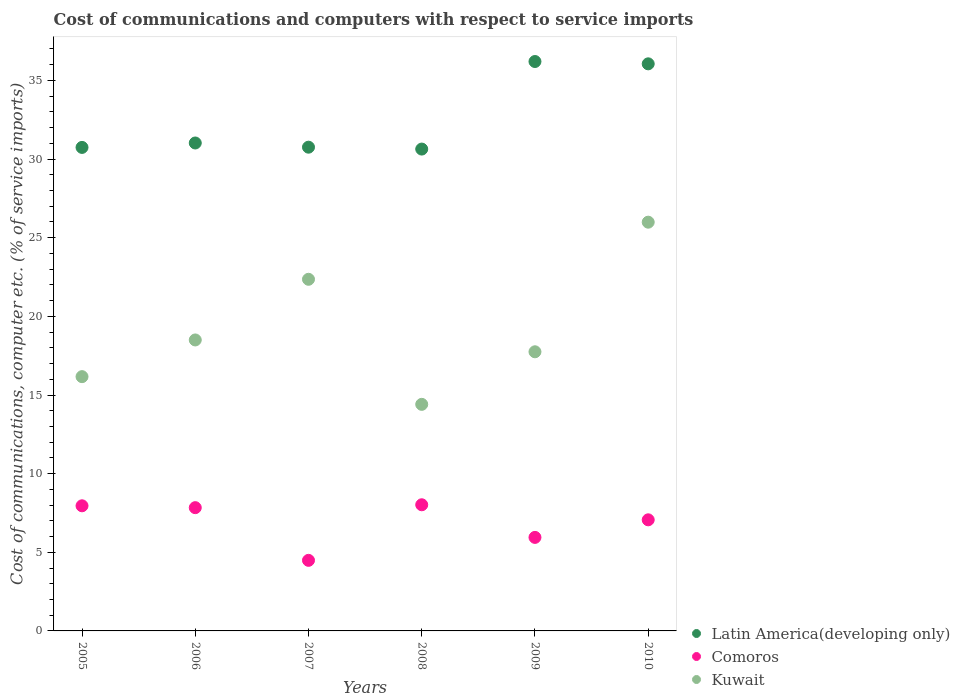Is the number of dotlines equal to the number of legend labels?
Provide a succinct answer. Yes. What is the cost of communications and computers in Kuwait in 2006?
Your response must be concise. 18.5. Across all years, what is the maximum cost of communications and computers in Latin America(developing only)?
Offer a terse response. 36.2. Across all years, what is the minimum cost of communications and computers in Kuwait?
Make the answer very short. 14.41. In which year was the cost of communications and computers in Comoros minimum?
Ensure brevity in your answer.  2007. What is the total cost of communications and computers in Latin America(developing only) in the graph?
Provide a succinct answer. 195.42. What is the difference between the cost of communications and computers in Comoros in 2006 and that in 2008?
Offer a very short reply. -0.18. What is the difference between the cost of communications and computers in Kuwait in 2008 and the cost of communications and computers in Comoros in 2009?
Your response must be concise. 8.46. What is the average cost of communications and computers in Latin America(developing only) per year?
Provide a short and direct response. 32.57. In the year 2010, what is the difference between the cost of communications and computers in Comoros and cost of communications and computers in Latin America(developing only)?
Provide a succinct answer. -28.99. What is the ratio of the cost of communications and computers in Kuwait in 2009 to that in 2010?
Provide a short and direct response. 0.68. Is the cost of communications and computers in Kuwait in 2008 less than that in 2009?
Make the answer very short. Yes. Is the difference between the cost of communications and computers in Comoros in 2005 and 2007 greater than the difference between the cost of communications and computers in Latin America(developing only) in 2005 and 2007?
Keep it short and to the point. Yes. What is the difference between the highest and the second highest cost of communications and computers in Comoros?
Give a very brief answer. 0.07. What is the difference between the highest and the lowest cost of communications and computers in Latin America(developing only)?
Give a very brief answer. 5.57. Is the sum of the cost of communications and computers in Kuwait in 2006 and 2010 greater than the maximum cost of communications and computers in Latin America(developing only) across all years?
Provide a short and direct response. Yes. How many dotlines are there?
Offer a terse response. 3. What is the difference between two consecutive major ticks on the Y-axis?
Your answer should be compact. 5. Does the graph contain any zero values?
Provide a succinct answer. No. Does the graph contain grids?
Your answer should be very brief. No. Where does the legend appear in the graph?
Provide a short and direct response. Bottom right. How are the legend labels stacked?
Give a very brief answer. Vertical. What is the title of the graph?
Provide a short and direct response. Cost of communications and computers with respect to service imports. What is the label or title of the Y-axis?
Keep it short and to the point. Cost of communications, computer etc. (% of service imports). What is the Cost of communications, computer etc. (% of service imports) in Latin America(developing only) in 2005?
Ensure brevity in your answer.  30.74. What is the Cost of communications, computer etc. (% of service imports) of Comoros in 2005?
Your answer should be very brief. 7.96. What is the Cost of communications, computer etc. (% of service imports) in Kuwait in 2005?
Your answer should be compact. 16.17. What is the Cost of communications, computer etc. (% of service imports) of Latin America(developing only) in 2006?
Provide a short and direct response. 31.02. What is the Cost of communications, computer etc. (% of service imports) in Comoros in 2006?
Offer a very short reply. 7.84. What is the Cost of communications, computer etc. (% of service imports) in Kuwait in 2006?
Make the answer very short. 18.5. What is the Cost of communications, computer etc. (% of service imports) of Latin America(developing only) in 2007?
Offer a very short reply. 30.76. What is the Cost of communications, computer etc. (% of service imports) in Comoros in 2007?
Give a very brief answer. 4.49. What is the Cost of communications, computer etc. (% of service imports) of Kuwait in 2007?
Make the answer very short. 22.36. What is the Cost of communications, computer etc. (% of service imports) in Latin America(developing only) in 2008?
Provide a short and direct response. 30.64. What is the Cost of communications, computer etc. (% of service imports) of Comoros in 2008?
Your answer should be compact. 8.02. What is the Cost of communications, computer etc. (% of service imports) in Kuwait in 2008?
Keep it short and to the point. 14.41. What is the Cost of communications, computer etc. (% of service imports) of Latin America(developing only) in 2009?
Offer a terse response. 36.2. What is the Cost of communications, computer etc. (% of service imports) of Comoros in 2009?
Offer a terse response. 5.95. What is the Cost of communications, computer etc. (% of service imports) of Kuwait in 2009?
Offer a terse response. 17.75. What is the Cost of communications, computer etc. (% of service imports) of Latin America(developing only) in 2010?
Give a very brief answer. 36.06. What is the Cost of communications, computer etc. (% of service imports) in Comoros in 2010?
Provide a succinct answer. 7.06. What is the Cost of communications, computer etc. (% of service imports) in Kuwait in 2010?
Your answer should be very brief. 25.99. Across all years, what is the maximum Cost of communications, computer etc. (% of service imports) in Latin America(developing only)?
Ensure brevity in your answer.  36.2. Across all years, what is the maximum Cost of communications, computer etc. (% of service imports) of Comoros?
Ensure brevity in your answer.  8.02. Across all years, what is the maximum Cost of communications, computer etc. (% of service imports) in Kuwait?
Provide a short and direct response. 25.99. Across all years, what is the minimum Cost of communications, computer etc. (% of service imports) of Latin America(developing only)?
Provide a short and direct response. 30.64. Across all years, what is the minimum Cost of communications, computer etc. (% of service imports) in Comoros?
Provide a short and direct response. 4.49. Across all years, what is the minimum Cost of communications, computer etc. (% of service imports) in Kuwait?
Offer a very short reply. 14.41. What is the total Cost of communications, computer etc. (% of service imports) in Latin America(developing only) in the graph?
Give a very brief answer. 195.42. What is the total Cost of communications, computer etc. (% of service imports) of Comoros in the graph?
Provide a succinct answer. 41.31. What is the total Cost of communications, computer etc. (% of service imports) of Kuwait in the graph?
Your answer should be compact. 115.17. What is the difference between the Cost of communications, computer etc. (% of service imports) of Latin America(developing only) in 2005 and that in 2006?
Offer a terse response. -0.28. What is the difference between the Cost of communications, computer etc. (% of service imports) in Comoros in 2005 and that in 2006?
Offer a very short reply. 0.12. What is the difference between the Cost of communications, computer etc. (% of service imports) of Kuwait in 2005 and that in 2006?
Make the answer very short. -2.33. What is the difference between the Cost of communications, computer etc. (% of service imports) in Latin America(developing only) in 2005 and that in 2007?
Provide a short and direct response. -0.01. What is the difference between the Cost of communications, computer etc. (% of service imports) of Comoros in 2005 and that in 2007?
Provide a succinct answer. 3.47. What is the difference between the Cost of communications, computer etc. (% of service imports) in Kuwait in 2005 and that in 2007?
Your answer should be compact. -6.19. What is the difference between the Cost of communications, computer etc. (% of service imports) of Latin America(developing only) in 2005 and that in 2008?
Offer a very short reply. 0.11. What is the difference between the Cost of communications, computer etc. (% of service imports) of Comoros in 2005 and that in 2008?
Provide a short and direct response. -0.07. What is the difference between the Cost of communications, computer etc. (% of service imports) of Kuwait in 2005 and that in 2008?
Ensure brevity in your answer.  1.76. What is the difference between the Cost of communications, computer etc. (% of service imports) of Latin America(developing only) in 2005 and that in 2009?
Provide a succinct answer. -5.46. What is the difference between the Cost of communications, computer etc. (% of service imports) of Comoros in 2005 and that in 2009?
Ensure brevity in your answer.  2.01. What is the difference between the Cost of communications, computer etc. (% of service imports) in Kuwait in 2005 and that in 2009?
Offer a terse response. -1.58. What is the difference between the Cost of communications, computer etc. (% of service imports) in Latin America(developing only) in 2005 and that in 2010?
Make the answer very short. -5.31. What is the difference between the Cost of communications, computer etc. (% of service imports) of Comoros in 2005 and that in 2010?
Your response must be concise. 0.89. What is the difference between the Cost of communications, computer etc. (% of service imports) of Kuwait in 2005 and that in 2010?
Provide a succinct answer. -9.82. What is the difference between the Cost of communications, computer etc. (% of service imports) of Latin America(developing only) in 2006 and that in 2007?
Give a very brief answer. 0.27. What is the difference between the Cost of communications, computer etc. (% of service imports) of Comoros in 2006 and that in 2007?
Your answer should be very brief. 3.35. What is the difference between the Cost of communications, computer etc. (% of service imports) in Kuwait in 2006 and that in 2007?
Your response must be concise. -3.86. What is the difference between the Cost of communications, computer etc. (% of service imports) of Latin America(developing only) in 2006 and that in 2008?
Give a very brief answer. 0.39. What is the difference between the Cost of communications, computer etc. (% of service imports) in Comoros in 2006 and that in 2008?
Keep it short and to the point. -0.18. What is the difference between the Cost of communications, computer etc. (% of service imports) in Kuwait in 2006 and that in 2008?
Your answer should be very brief. 4.09. What is the difference between the Cost of communications, computer etc. (% of service imports) of Latin America(developing only) in 2006 and that in 2009?
Your response must be concise. -5.18. What is the difference between the Cost of communications, computer etc. (% of service imports) in Comoros in 2006 and that in 2009?
Offer a terse response. 1.89. What is the difference between the Cost of communications, computer etc. (% of service imports) in Kuwait in 2006 and that in 2009?
Offer a very short reply. 0.75. What is the difference between the Cost of communications, computer etc. (% of service imports) in Latin America(developing only) in 2006 and that in 2010?
Provide a succinct answer. -5.03. What is the difference between the Cost of communications, computer etc. (% of service imports) in Comoros in 2006 and that in 2010?
Make the answer very short. 0.77. What is the difference between the Cost of communications, computer etc. (% of service imports) in Kuwait in 2006 and that in 2010?
Provide a succinct answer. -7.49. What is the difference between the Cost of communications, computer etc. (% of service imports) in Latin America(developing only) in 2007 and that in 2008?
Offer a terse response. 0.12. What is the difference between the Cost of communications, computer etc. (% of service imports) of Comoros in 2007 and that in 2008?
Offer a very short reply. -3.53. What is the difference between the Cost of communications, computer etc. (% of service imports) in Kuwait in 2007 and that in 2008?
Your answer should be very brief. 7.95. What is the difference between the Cost of communications, computer etc. (% of service imports) in Latin America(developing only) in 2007 and that in 2009?
Offer a very short reply. -5.45. What is the difference between the Cost of communications, computer etc. (% of service imports) of Comoros in 2007 and that in 2009?
Offer a very short reply. -1.46. What is the difference between the Cost of communications, computer etc. (% of service imports) in Kuwait in 2007 and that in 2009?
Your answer should be very brief. 4.61. What is the difference between the Cost of communications, computer etc. (% of service imports) in Latin America(developing only) in 2007 and that in 2010?
Your answer should be very brief. -5.3. What is the difference between the Cost of communications, computer etc. (% of service imports) in Comoros in 2007 and that in 2010?
Offer a very short reply. -2.58. What is the difference between the Cost of communications, computer etc. (% of service imports) in Kuwait in 2007 and that in 2010?
Your response must be concise. -3.63. What is the difference between the Cost of communications, computer etc. (% of service imports) in Latin America(developing only) in 2008 and that in 2009?
Offer a very short reply. -5.57. What is the difference between the Cost of communications, computer etc. (% of service imports) of Comoros in 2008 and that in 2009?
Provide a succinct answer. 2.07. What is the difference between the Cost of communications, computer etc. (% of service imports) in Kuwait in 2008 and that in 2009?
Offer a terse response. -3.34. What is the difference between the Cost of communications, computer etc. (% of service imports) in Latin America(developing only) in 2008 and that in 2010?
Give a very brief answer. -5.42. What is the difference between the Cost of communications, computer etc. (% of service imports) in Comoros in 2008 and that in 2010?
Provide a succinct answer. 0.96. What is the difference between the Cost of communications, computer etc. (% of service imports) in Kuwait in 2008 and that in 2010?
Offer a terse response. -11.58. What is the difference between the Cost of communications, computer etc. (% of service imports) of Latin America(developing only) in 2009 and that in 2010?
Your response must be concise. 0.15. What is the difference between the Cost of communications, computer etc. (% of service imports) in Comoros in 2009 and that in 2010?
Provide a succinct answer. -1.12. What is the difference between the Cost of communications, computer etc. (% of service imports) in Kuwait in 2009 and that in 2010?
Offer a terse response. -8.24. What is the difference between the Cost of communications, computer etc. (% of service imports) in Latin America(developing only) in 2005 and the Cost of communications, computer etc. (% of service imports) in Comoros in 2006?
Ensure brevity in your answer.  22.91. What is the difference between the Cost of communications, computer etc. (% of service imports) of Latin America(developing only) in 2005 and the Cost of communications, computer etc. (% of service imports) of Kuwait in 2006?
Keep it short and to the point. 12.24. What is the difference between the Cost of communications, computer etc. (% of service imports) in Comoros in 2005 and the Cost of communications, computer etc. (% of service imports) in Kuwait in 2006?
Provide a short and direct response. -10.54. What is the difference between the Cost of communications, computer etc. (% of service imports) of Latin America(developing only) in 2005 and the Cost of communications, computer etc. (% of service imports) of Comoros in 2007?
Offer a terse response. 26.25. What is the difference between the Cost of communications, computer etc. (% of service imports) in Latin America(developing only) in 2005 and the Cost of communications, computer etc. (% of service imports) in Kuwait in 2007?
Ensure brevity in your answer.  8.38. What is the difference between the Cost of communications, computer etc. (% of service imports) of Comoros in 2005 and the Cost of communications, computer etc. (% of service imports) of Kuwait in 2007?
Your answer should be very brief. -14.4. What is the difference between the Cost of communications, computer etc. (% of service imports) in Latin America(developing only) in 2005 and the Cost of communications, computer etc. (% of service imports) in Comoros in 2008?
Your response must be concise. 22.72. What is the difference between the Cost of communications, computer etc. (% of service imports) of Latin America(developing only) in 2005 and the Cost of communications, computer etc. (% of service imports) of Kuwait in 2008?
Your response must be concise. 16.34. What is the difference between the Cost of communications, computer etc. (% of service imports) in Comoros in 2005 and the Cost of communications, computer etc. (% of service imports) in Kuwait in 2008?
Ensure brevity in your answer.  -6.45. What is the difference between the Cost of communications, computer etc. (% of service imports) in Latin America(developing only) in 2005 and the Cost of communications, computer etc. (% of service imports) in Comoros in 2009?
Your response must be concise. 24.8. What is the difference between the Cost of communications, computer etc. (% of service imports) in Latin America(developing only) in 2005 and the Cost of communications, computer etc. (% of service imports) in Kuwait in 2009?
Give a very brief answer. 12.99. What is the difference between the Cost of communications, computer etc. (% of service imports) in Comoros in 2005 and the Cost of communications, computer etc. (% of service imports) in Kuwait in 2009?
Your answer should be very brief. -9.79. What is the difference between the Cost of communications, computer etc. (% of service imports) in Latin America(developing only) in 2005 and the Cost of communications, computer etc. (% of service imports) in Comoros in 2010?
Your response must be concise. 23.68. What is the difference between the Cost of communications, computer etc. (% of service imports) of Latin America(developing only) in 2005 and the Cost of communications, computer etc. (% of service imports) of Kuwait in 2010?
Provide a succinct answer. 4.75. What is the difference between the Cost of communications, computer etc. (% of service imports) in Comoros in 2005 and the Cost of communications, computer etc. (% of service imports) in Kuwait in 2010?
Your answer should be compact. -18.03. What is the difference between the Cost of communications, computer etc. (% of service imports) of Latin America(developing only) in 2006 and the Cost of communications, computer etc. (% of service imports) of Comoros in 2007?
Provide a short and direct response. 26.54. What is the difference between the Cost of communications, computer etc. (% of service imports) in Latin America(developing only) in 2006 and the Cost of communications, computer etc. (% of service imports) in Kuwait in 2007?
Keep it short and to the point. 8.67. What is the difference between the Cost of communications, computer etc. (% of service imports) of Comoros in 2006 and the Cost of communications, computer etc. (% of service imports) of Kuwait in 2007?
Provide a succinct answer. -14.52. What is the difference between the Cost of communications, computer etc. (% of service imports) in Latin America(developing only) in 2006 and the Cost of communications, computer etc. (% of service imports) in Comoros in 2008?
Keep it short and to the point. 23. What is the difference between the Cost of communications, computer etc. (% of service imports) in Latin America(developing only) in 2006 and the Cost of communications, computer etc. (% of service imports) in Kuwait in 2008?
Keep it short and to the point. 16.62. What is the difference between the Cost of communications, computer etc. (% of service imports) of Comoros in 2006 and the Cost of communications, computer etc. (% of service imports) of Kuwait in 2008?
Give a very brief answer. -6.57. What is the difference between the Cost of communications, computer etc. (% of service imports) in Latin America(developing only) in 2006 and the Cost of communications, computer etc. (% of service imports) in Comoros in 2009?
Your answer should be very brief. 25.08. What is the difference between the Cost of communications, computer etc. (% of service imports) of Latin America(developing only) in 2006 and the Cost of communications, computer etc. (% of service imports) of Kuwait in 2009?
Give a very brief answer. 13.28. What is the difference between the Cost of communications, computer etc. (% of service imports) of Comoros in 2006 and the Cost of communications, computer etc. (% of service imports) of Kuwait in 2009?
Provide a succinct answer. -9.91. What is the difference between the Cost of communications, computer etc. (% of service imports) of Latin America(developing only) in 2006 and the Cost of communications, computer etc. (% of service imports) of Comoros in 2010?
Provide a succinct answer. 23.96. What is the difference between the Cost of communications, computer etc. (% of service imports) of Latin America(developing only) in 2006 and the Cost of communications, computer etc. (% of service imports) of Kuwait in 2010?
Give a very brief answer. 5.03. What is the difference between the Cost of communications, computer etc. (% of service imports) of Comoros in 2006 and the Cost of communications, computer etc. (% of service imports) of Kuwait in 2010?
Offer a very short reply. -18.15. What is the difference between the Cost of communications, computer etc. (% of service imports) of Latin America(developing only) in 2007 and the Cost of communications, computer etc. (% of service imports) of Comoros in 2008?
Your answer should be compact. 22.74. What is the difference between the Cost of communications, computer etc. (% of service imports) of Latin America(developing only) in 2007 and the Cost of communications, computer etc. (% of service imports) of Kuwait in 2008?
Your answer should be very brief. 16.35. What is the difference between the Cost of communications, computer etc. (% of service imports) of Comoros in 2007 and the Cost of communications, computer etc. (% of service imports) of Kuwait in 2008?
Make the answer very short. -9.92. What is the difference between the Cost of communications, computer etc. (% of service imports) in Latin America(developing only) in 2007 and the Cost of communications, computer etc. (% of service imports) in Comoros in 2009?
Provide a succinct answer. 24.81. What is the difference between the Cost of communications, computer etc. (% of service imports) of Latin America(developing only) in 2007 and the Cost of communications, computer etc. (% of service imports) of Kuwait in 2009?
Keep it short and to the point. 13.01. What is the difference between the Cost of communications, computer etc. (% of service imports) in Comoros in 2007 and the Cost of communications, computer etc. (% of service imports) in Kuwait in 2009?
Provide a short and direct response. -13.26. What is the difference between the Cost of communications, computer etc. (% of service imports) in Latin America(developing only) in 2007 and the Cost of communications, computer etc. (% of service imports) in Comoros in 2010?
Your response must be concise. 23.69. What is the difference between the Cost of communications, computer etc. (% of service imports) of Latin America(developing only) in 2007 and the Cost of communications, computer etc. (% of service imports) of Kuwait in 2010?
Offer a terse response. 4.77. What is the difference between the Cost of communications, computer etc. (% of service imports) of Comoros in 2007 and the Cost of communications, computer etc. (% of service imports) of Kuwait in 2010?
Keep it short and to the point. -21.5. What is the difference between the Cost of communications, computer etc. (% of service imports) of Latin America(developing only) in 2008 and the Cost of communications, computer etc. (% of service imports) of Comoros in 2009?
Ensure brevity in your answer.  24.69. What is the difference between the Cost of communications, computer etc. (% of service imports) of Latin America(developing only) in 2008 and the Cost of communications, computer etc. (% of service imports) of Kuwait in 2009?
Your answer should be compact. 12.89. What is the difference between the Cost of communications, computer etc. (% of service imports) of Comoros in 2008 and the Cost of communications, computer etc. (% of service imports) of Kuwait in 2009?
Your answer should be very brief. -9.73. What is the difference between the Cost of communications, computer etc. (% of service imports) of Latin America(developing only) in 2008 and the Cost of communications, computer etc. (% of service imports) of Comoros in 2010?
Your response must be concise. 23.57. What is the difference between the Cost of communications, computer etc. (% of service imports) of Latin America(developing only) in 2008 and the Cost of communications, computer etc. (% of service imports) of Kuwait in 2010?
Provide a succinct answer. 4.65. What is the difference between the Cost of communications, computer etc. (% of service imports) of Comoros in 2008 and the Cost of communications, computer etc. (% of service imports) of Kuwait in 2010?
Your answer should be very brief. -17.97. What is the difference between the Cost of communications, computer etc. (% of service imports) of Latin America(developing only) in 2009 and the Cost of communications, computer etc. (% of service imports) of Comoros in 2010?
Your answer should be very brief. 29.14. What is the difference between the Cost of communications, computer etc. (% of service imports) of Latin America(developing only) in 2009 and the Cost of communications, computer etc. (% of service imports) of Kuwait in 2010?
Make the answer very short. 10.21. What is the difference between the Cost of communications, computer etc. (% of service imports) in Comoros in 2009 and the Cost of communications, computer etc. (% of service imports) in Kuwait in 2010?
Give a very brief answer. -20.04. What is the average Cost of communications, computer etc. (% of service imports) of Latin America(developing only) per year?
Provide a succinct answer. 32.57. What is the average Cost of communications, computer etc. (% of service imports) of Comoros per year?
Your answer should be very brief. 6.89. What is the average Cost of communications, computer etc. (% of service imports) in Kuwait per year?
Make the answer very short. 19.19. In the year 2005, what is the difference between the Cost of communications, computer etc. (% of service imports) of Latin America(developing only) and Cost of communications, computer etc. (% of service imports) of Comoros?
Your answer should be very brief. 22.79. In the year 2005, what is the difference between the Cost of communications, computer etc. (% of service imports) in Latin America(developing only) and Cost of communications, computer etc. (% of service imports) in Kuwait?
Your response must be concise. 14.58. In the year 2005, what is the difference between the Cost of communications, computer etc. (% of service imports) in Comoros and Cost of communications, computer etc. (% of service imports) in Kuwait?
Provide a short and direct response. -8.21. In the year 2006, what is the difference between the Cost of communications, computer etc. (% of service imports) of Latin America(developing only) and Cost of communications, computer etc. (% of service imports) of Comoros?
Offer a very short reply. 23.19. In the year 2006, what is the difference between the Cost of communications, computer etc. (% of service imports) of Latin America(developing only) and Cost of communications, computer etc. (% of service imports) of Kuwait?
Your response must be concise. 12.52. In the year 2006, what is the difference between the Cost of communications, computer etc. (% of service imports) of Comoros and Cost of communications, computer etc. (% of service imports) of Kuwait?
Provide a succinct answer. -10.66. In the year 2007, what is the difference between the Cost of communications, computer etc. (% of service imports) in Latin America(developing only) and Cost of communications, computer etc. (% of service imports) in Comoros?
Make the answer very short. 26.27. In the year 2007, what is the difference between the Cost of communications, computer etc. (% of service imports) in Latin America(developing only) and Cost of communications, computer etc. (% of service imports) in Kuwait?
Your response must be concise. 8.4. In the year 2007, what is the difference between the Cost of communications, computer etc. (% of service imports) in Comoros and Cost of communications, computer etc. (% of service imports) in Kuwait?
Provide a succinct answer. -17.87. In the year 2008, what is the difference between the Cost of communications, computer etc. (% of service imports) in Latin America(developing only) and Cost of communications, computer etc. (% of service imports) in Comoros?
Provide a succinct answer. 22.62. In the year 2008, what is the difference between the Cost of communications, computer etc. (% of service imports) in Latin America(developing only) and Cost of communications, computer etc. (% of service imports) in Kuwait?
Keep it short and to the point. 16.23. In the year 2008, what is the difference between the Cost of communications, computer etc. (% of service imports) of Comoros and Cost of communications, computer etc. (% of service imports) of Kuwait?
Give a very brief answer. -6.38. In the year 2009, what is the difference between the Cost of communications, computer etc. (% of service imports) in Latin America(developing only) and Cost of communications, computer etc. (% of service imports) in Comoros?
Your response must be concise. 30.26. In the year 2009, what is the difference between the Cost of communications, computer etc. (% of service imports) in Latin America(developing only) and Cost of communications, computer etc. (% of service imports) in Kuwait?
Give a very brief answer. 18.46. In the year 2009, what is the difference between the Cost of communications, computer etc. (% of service imports) in Comoros and Cost of communications, computer etc. (% of service imports) in Kuwait?
Offer a terse response. -11.8. In the year 2010, what is the difference between the Cost of communications, computer etc. (% of service imports) of Latin America(developing only) and Cost of communications, computer etc. (% of service imports) of Comoros?
Keep it short and to the point. 28.99. In the year 2010, what is the difference between the Cost of communications, computer etc. (% of service imports) of Latin America(developing only) and Cost of communications, computer etc. (% of service imports) of Kuwait?
Provide a short and direct response. 10.07. In the year 2010, what is the difference between the Cost of communications, computer etc. (% of service imports) in Comoros and Cost of communications, computer etc. (% of service imports) in Kuwait?
Your answer should be very brief. -18.92. What is the ratio of the Cost of communications, computer etc. (% of service imports) of Latin America(developing only) in 2005 to that in 2006?
Offer a terse response. 0.99. What is the ratio of the Cost of communications, computer etc. (% of service imports) in Comoros in 2005 to that in 2006?
Your response must be concise. 1.02. What is the ratio of the Cost of communications, computer etc. (% of service imports) of Kuwait in 2005 to that in 2006?
Offer a very short reply. 0.87. What is the ratio of the Cost of communications, computer etc. (% of service imports) of Comoros in 2005 to that in 2007?
Offer a very short reply. 1.77. What is the ratio of the Cost of communications, computer etc. (% of service imports) in Kuwait in 2005 to that in 2007?
Provide a short and direct response. 0.72. What is the ratio of the Cost of communications, computer etc. (% of service imports) of Latin America(developing only) in 2005 to that in 2008?
Ensure brevity in your answer.  1. What is the ratio of the Cost of communications, computer etc. (% of service imports) in Kuwait in 2005 to that in 2008?
Keep it short and to the point. 1.12. What is the ratio of the Cost of communications, computer etc. (% of service imports) in Latin America(developing only) in 2005 to that in 2009?
Your answer should be very brief. 0.85. What is the ratio of the Cost of communications, computer etc. (% of service imports) in Comoros in 2005 to that in 2009?
Give a very brief answer. 1.34. What is the ratio of the Cost of communications, computer etc. (% of service imports) in Kuwait in 2005 to that in 2009?
Provide a succinct answer. 0.91. What is the ratio of the Cost of communications, computer etc. (% of service imports) of Latin America(developing only) in 2005 to that in 2010?
Ensure brevity in your answer.  0.85. What is the ratio of the Cost of communications, computer etc. (% of service imports) of Comoros in 2005 to that in 2010?
Keep it short and to the point. 1.13. What is the ratio of the Cost of communications, computer etc. (% of service imports) in Kuwait in 2005 to that in 2010?
Give a very brief answer. 0.62. What is the ratio of the Cost of communications, computer etc. (% of service imports) of Latin America(developing only) in 2006 to that in 2007?
Provide a succinct answer. 1.01. What is the ratio of the Cost of communications, computer etc. (% of service imports) in Comoros in 2006 to that in 2007?
Ensure brevity in your answer.  1.75. What is the ratio of the Cost of communications, computer etc. (% of service imports) of Kuwait in 2006 to that in 2007?
Provide a short and direct response. 0.83. What is the ratio of the Cost of communications, computer etc. (% of service imports) of Latin America(developing only) in 2006 to that in 2008?
Keep it short and to the point. 1.01. What is the ratio of the Cost of communications, computer etc. (% of service imports) of Comoros in 2006 to that in 2008?
Ensure brevity in your answer.  0.98. What is the ratio of the Cost of communications, computer etc. (% of service imports) in Kuwait in 2006 to that in 2008?
Your response must be concise. 1.28. What is the ratio of the Cost of communications, computer etc. (% of service imports) of Latin America(developing only) in 2006 to that in 2009?
Your answer should be very brief. 0.86. What is the ratio of the Cost of communications, computer etc. (% of service imports) in Comoros in 2006 to that in 2009?
Keep it short and to the point. 1.32. What is the ratio of the Cost of communications, computer etc. (% of service imports) in Kuwait in 2006 to that in 2009?
Keep it short and to the point. 1.04. What is the ratio of the Cost of communications, computer etc. (% of service imports) of Latin America(developing only) in 2006 to that in 2010?
Give a very brief answer. 0.86. What is the ratio of the Cost of communications, computer etc. (% of service imports) of Comoros in 2006 to that in 2010?
Provide a short and direct response. 1.11. What is the ratio of the Cost of communications, computer etc. (% of service imports) of Kuwait in 2006 to that in 2010?
Make the answer very short. 0.71. What is the ratio of the Cost of communications, computer etc. (% of service imports) in Comoros in 2007 to that in 2008?
Offer a very short reply. 0.56. What is the ratio of the Cost of communications, computer etc. (% of service imports) of Kuwait in 2007 to that in 2008?
Provide a succinct answer. 1.55. What is the ratio of the Cost of communications, computer etc. (% of service imports) of Latin America(developing only) in 2007 to that in 2009?
Give a very brief answer. 0.85. What is the ratio of the Cost of communications, computer etc. (% of service imports) of Comoros in 2007 to that in 2009?
Your response must be concise. 0.75. What is the ratio of the Cost of communications, computer etc. (% of service imports) of Kuwait in 2007 to that in 2009?
Your answer should be compact. 1.26. What is the ratio of the Cost of communications, computer etc. (% of service imports) in Latin America(developing only) in 2007 to that in 2010?
Your answer should be compact. 0.85. What is the ratio of the Cost of communications, computer etc. (% of service imports) of Comoros in 2007 to that in 2010?
Provide a short and direct response. 0.64. What is the ratio of the Cost of communications, computer etc. (% of service imports) of Kuwait in 2007 to that in 2010?
Your answer should be compact. 0.86. What is the ratio of the Cost of communications, computer etc. (% of service imports) in Latin America(developing only) in 2008 to that in 2009?
Keep it short and to the point. 0.85. What is the ratio of the Cost of communications, computer etc. (% of service imports) in Comoros in 2008 to that in 2009?
Offer a terse response. 1.35. What is the ratio of the Cost of communications, computer etc. (% of service imports) in Kuwait in 2008 to that in 2009?
Your response must be concise. 0.81. What is the ratio of the Cost of communications, computer etc. (% of service imports) of Latin America(developing only) in 2008 to that in 2010?
Offer a terse response. 0.85. What is the ratio of the Cost of communications, computer etc. (% of service imports) of Comoros in 2008 to that in 2010?
Make the answer very short. 1.14. What is the ratio of the Cost of communications, computer etc. (% of service imports) of Kuwait in 2008 to that in 2010?
Give a very brief answer. 0.55. What is the ratio of the Cost of communications, computer etc. (% of service imports) in Comoros in 2009 to that in 2010?
Your response must be concise. 0.84. What is the ratio of the Cost of communications, computer etc. (% of service imports) of Kuwait in 2009 to that in 2010?
Make the answer very short. 0.68. What is the difference between the highest and the second highest Cost of communications, computer etc. (% of service imports) of Latin America(developing only)?
Ensure brevity in your answer.  0.15. What is the difference between the highest and the second highest Cost of communications, computer etc. (% of service imports) of Comoros?
Your answer should be compact. 0.07. What is the difference between the highest and the second highest Cost of communications, computer etc. (% of service imports) in Kuwait?
Ensure brevity in your answer.  3.63. What is the difference between the highest and the lowest Cost of communications, computer etc. (% of service imports) of Latin America(developing only)?
Your answer should be compact. 5.57. What is the difference between the highest and the lowest Cost of communications, computer etc. (% of service imports) in Comoros?
Your answer should be very brief. 3.53. What is the difference between the highest and the lowest Cost of communications, computer etc. (% of service imports) of Kuwait?
Keep it short and to the point. 11.58. 